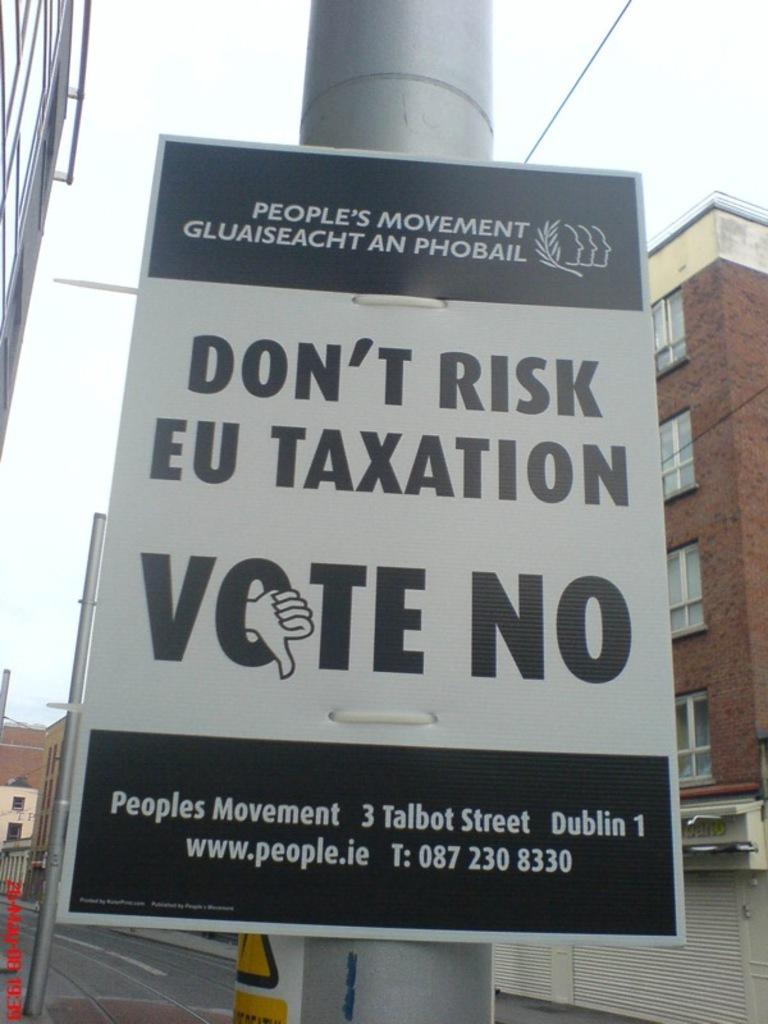What do they want you to vote?
Keep it short and to the point. No. Where is peoples movement located?
Give a very brief answer. Dublin. 